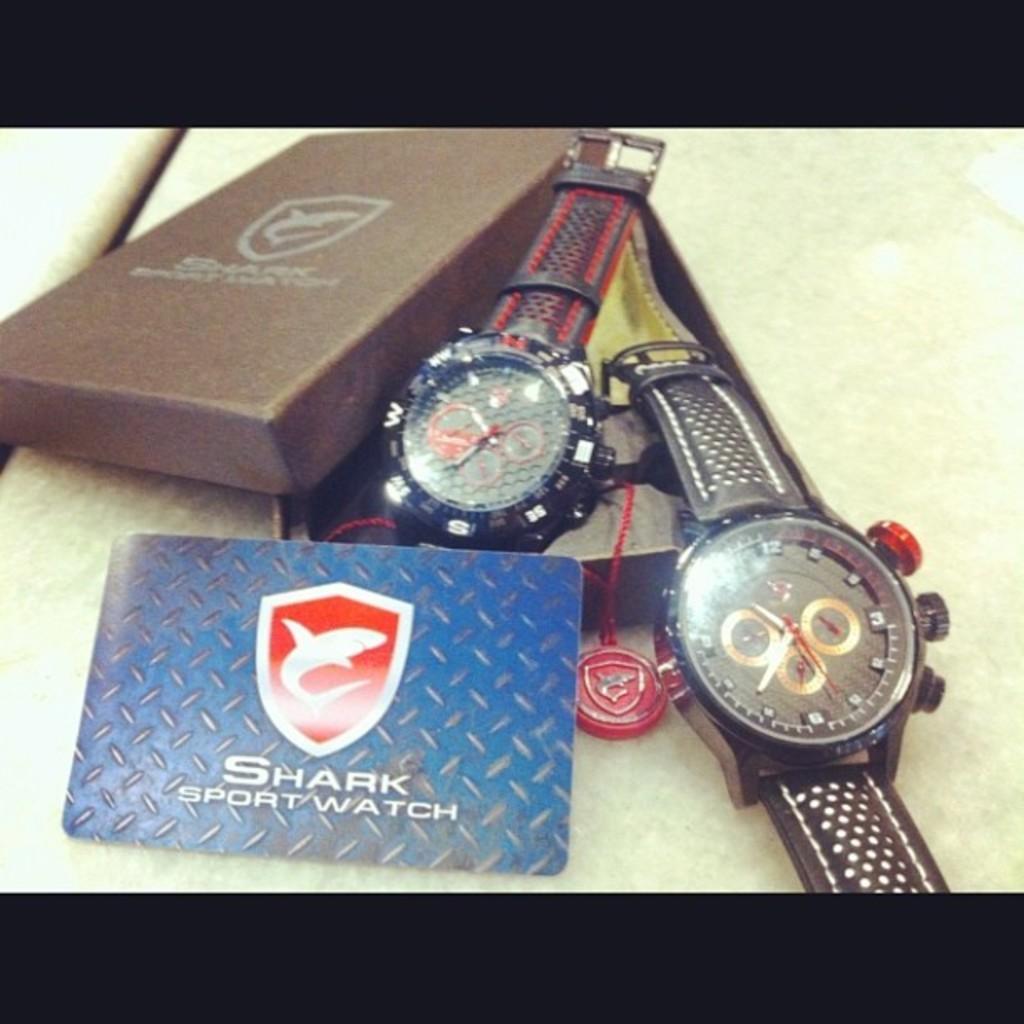What brand of watch?
Make the answer very short. Shark. What animal is on the logo?
Your response must be concise. Shark. 